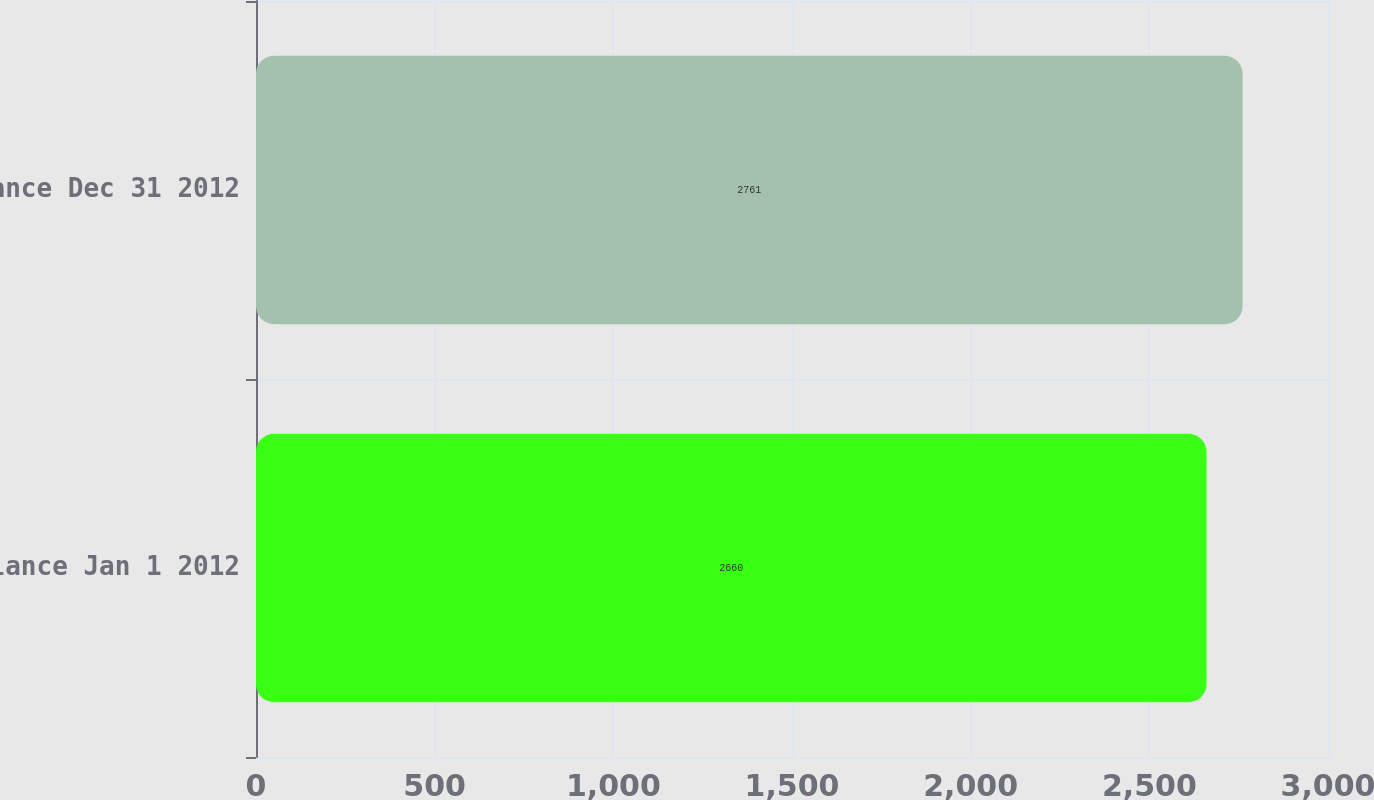Convert chart. <chart><loc_0><loc_0><loc_500><loc_500><bar_chart><fcel>Balance Jan 1 2012<fcel>Balance Dec 31 2012<nl><fcel>2660<fcel>2761<nl></chart> 